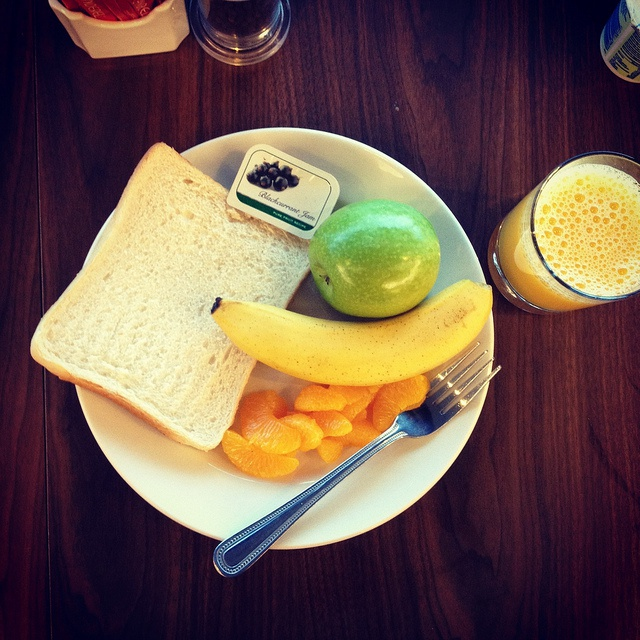Describe the objects in this image and their specific colors. I can see dining table in black, khaki, purple, beige, and gold tones, sandwich in black, khaki, lightyellow, and tan tones, cup in black, khaki, orange, and tan tones, banana in black, gold, khaki, and orange tones, and apple in black, olive, and lightgreen tones in this image. 